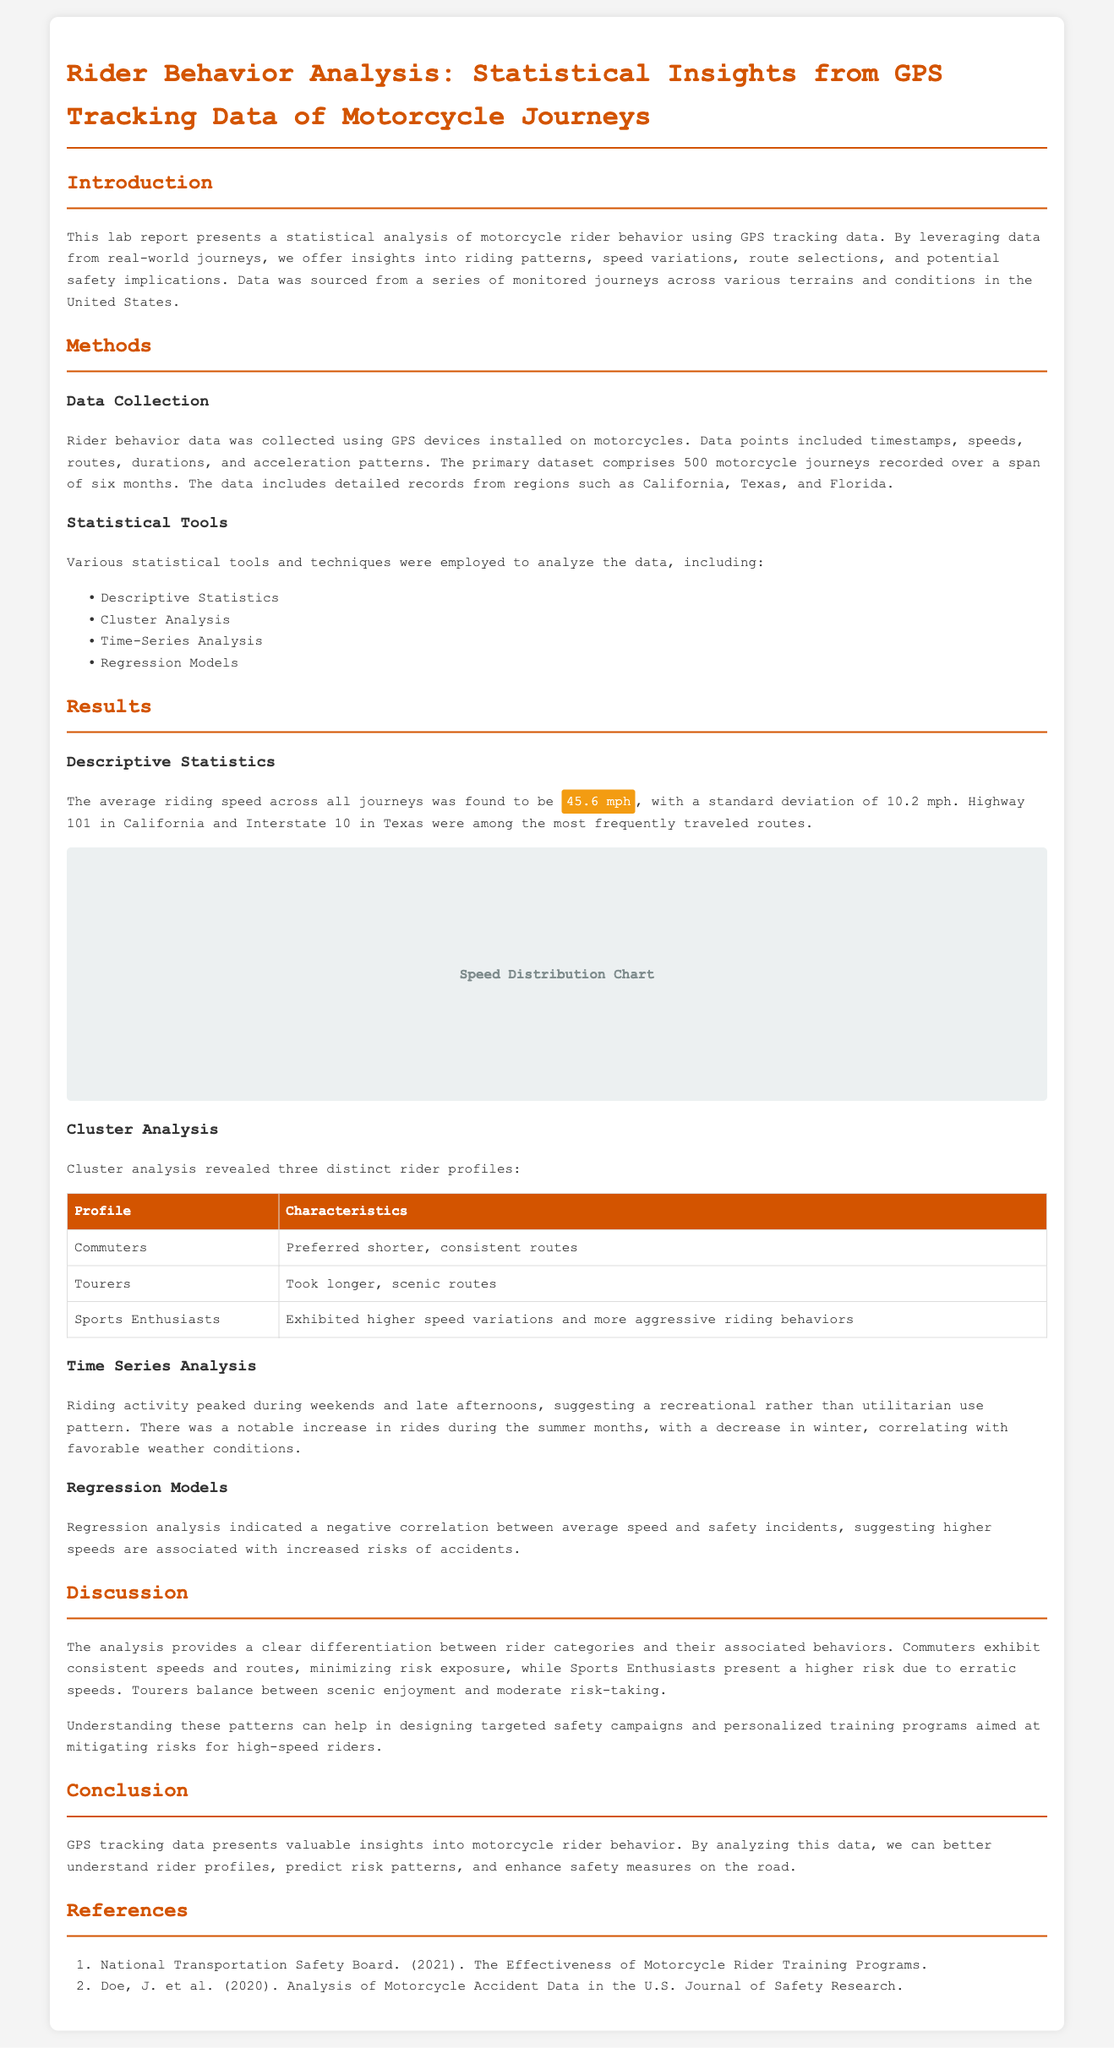what was the average riding speed? The average riding speed across all journeys is stated in the document as 45.6 mph.
Answer: 45.6 mph what is the standard deviation of the riding speed? The document provides the standard deviation of the riding speed as 10.2 mph.
Answer: 10.2 mph which regions were included in the data collection? The document mentions California, Texas, and Florida as the regions where data was collected.
Answer: California, Texas, and Florida what are the three distinct rider profiles identified? The rider profiles identified in the document include Commuters, Tourers, and Sports Enthusiasts.
Answer: Commuters, Tourers, and Sports Enthusiasts what riding behavior pattern was observed during weekends? The document states that riding activity peaked during weekends.
Answer: Peaked during weekends how did the riding activity change during summer compared to winter? According to the document, there was a notable increase in rides during the summer months and a decrease in winter.
Answer: Increase in summer, decrease in winter what correlation was found between average speed and safety incidents? The regression analysis in the document indicated a negative correlation between average speed and safety incidents.
Answer: Negative correlation what specific statistical tools were utilized in the analysis? The document lists the statistical tools employed which include Descriptive Statistics, Cluster Analysis, Time-Series Analysis, and Regression Models.
Answer: Descriptive Statistics, Cluster Analysis, Time-Series Analysis, and Regression Models what main implication does the analysis provide regarding rider safety? The document emphasizes that understanding rider behaviors can help design targeted safety campaigns and training programs.
Answer: Targeted safety campaigns and training programs 